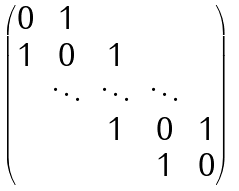Convert formula to latex. <formula><loc_0><loc_0><loc_500><loc_500>\begin{pmatrix} 0 & 1 \\ 1 & 0 & 1 \\ & \ddots & \ddots & \ddots \\ & & 1 & 0 & 1 \\ & & & 1 & 0 \end{pmatrix}</formula> 